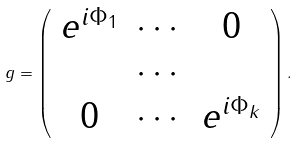<formula> <loc_0><loc_0><loc_500><loc_500>g = \left ( \begin{array} { c c c } e ^ { i \Phi _ { 1 } } & \cdots & 0 \\ & \cdots & \\ 0 & \cdots & e ^ { i \Phi _ { k } } \end{array} \right ) .</formula> 